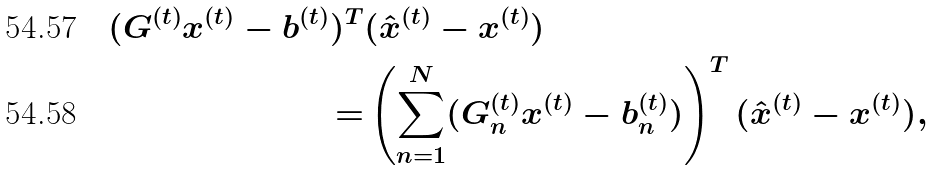Convert formula to latex. <formula><loc_0><loc_0><loc_500><loc_500>( G ^ { ( t ) } x ^ { ( t ) } - b ^ { ( t ) } ) ^ { T } & ( \hat { x } ^ { ( t ) } - x ^ { ( t ) } ) \\ = & \left ( \sum _ { n = 1 } ^ { N } ( G _ { n } ^ { ( t ) } x ^ { ( t ) } - b _ { n } ^ { ( t ) } ) \right ) ^ { T } ( \hat { x } ^ { ( t ) } - x ^ { ( t ) } ) ,</formula> 